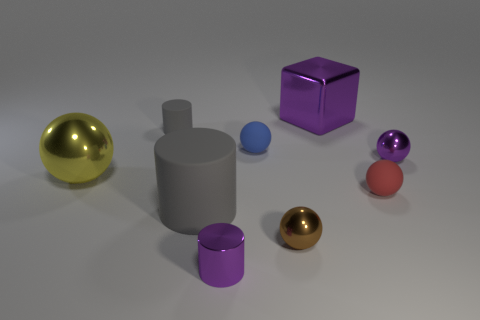There is a large rubber thing that is the same color as the tiny matte cylinder; what shape is it?
Give a very brief answer. Cylinder. Does the large cylinder have the same color as the tiny rubber cylinder?
Your answer should be compact. Yes. There is a object that is both behind the blue object and on the left side of the big metallic block; what is its shape?
Ensure brevity in your answer.  Cylinder. Are there any gray things behind the red object?
Make the answer very short. Yes. Is there anything else that has the same shape as the big purple shiny thing?
Give a very brief answer. No. Do the tiny gray thing and the big gray matte object have the same shape?
Provide a short and direct response. Yes. Are there an equal number of tiny brown things that are behind the tiny purple ball and brown shiny things to the right of the large purple shiny object?
Ensure brevity in your answer.  Yes. How many other objects are there of the same material as the purple sphere?
Keep it short and to the point. 4. How many small things are purple metallic balls or gray matte cylinders?
Give a very brief answer. 2. Are there the same number of tiny brown balls that are behind the tiny blue ball and tiny gray metal blocks?
Keep it short and to the point. Yes. 